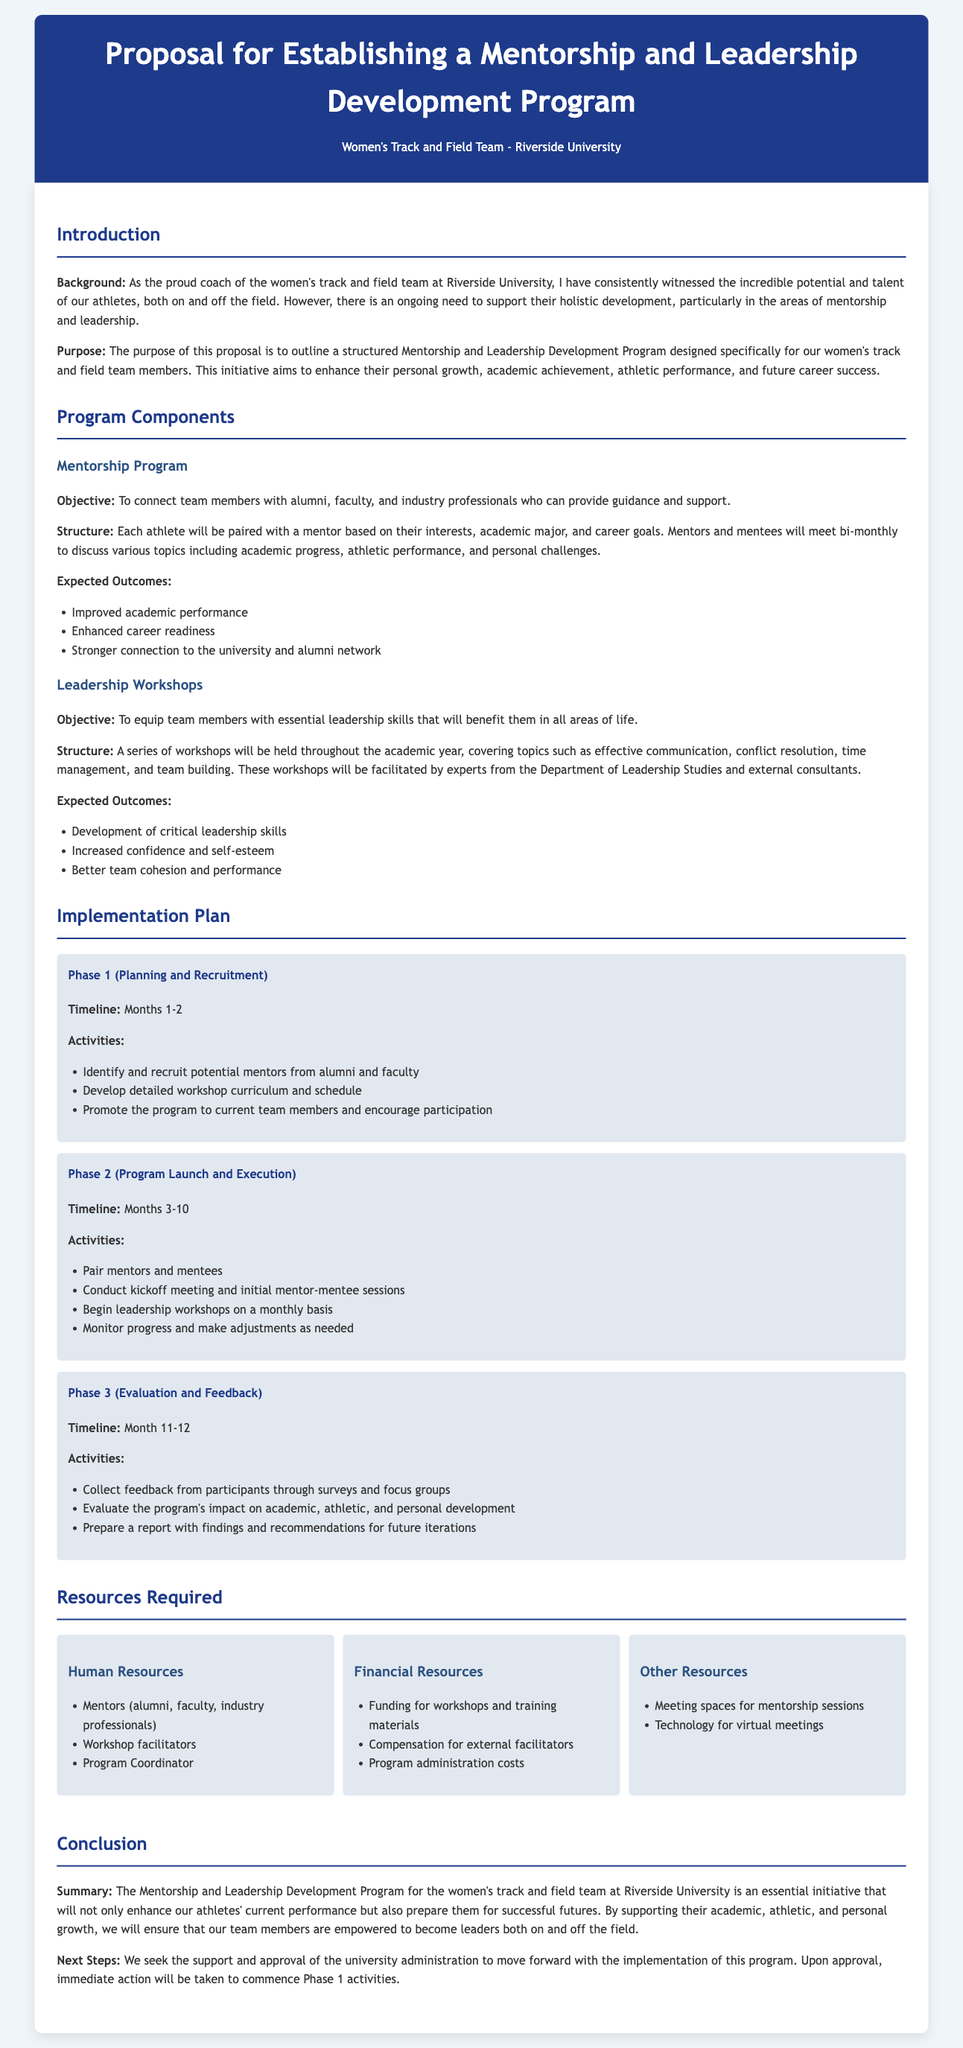what is the main purpose of the proposal? The primary aim is outlined in the section regarding purpose, emphasizing the proposal's goal to enhance personal growth, academic achievement, athletic performance, and future career success for team members.
Answer: enhance personal growth, academic achievement, athletic performance, and future career success what is the timeline for Phase 1? The timeline for Phase 1, which includes planning and recruitment, is explicitly mentioned, indicating the duration of this phase.
Answer: Months 1-2 how often will mentors and mentees meet? The meeting frequency between mentors and mentees is specified in the mentorship program structure section.
Answer: bi-monthly what are the expected outcomes of the mentorship program? A list of outcomes is provided in the mentorship program section, detailing the anticipated benefits for participants.
Answer: Improved academic performance, enhanced career readiness, stronger connection to the university and alumni network who will facilitate the leadership workshops? The document specifies that experts from the Department of Leadership Studies and external consultants will lead these workshops.
Answer: experts from the Department of Leadership Studies and external consultants what is the total duration of the program as described in the implementation plan? By adding the timelines of each phase outlined in the implementation plan, we derive the total length of the program.
Answer: 12 months what type of resources are needed for the program? The resources required are categorized in the document, detailing the human, financial, and other resources necessary for the program's success.
Answer: Human Resources, Financial Resources, Other Resources what activities are planned for Phase 2? The activities for Phase 2 are detailed and include various actions to be undertaken during the program launch and execution months.
Answer: Pair mentors and mentees, conduct kickoff meeting, begin leadership workshops, monitor progress what is the main goal of the leadership workshops? The objective of the leadership workshops is specified in the leadership workshops section, focusing on equipping participants with skills.
Answer: To equip team members with essential leadership skills 